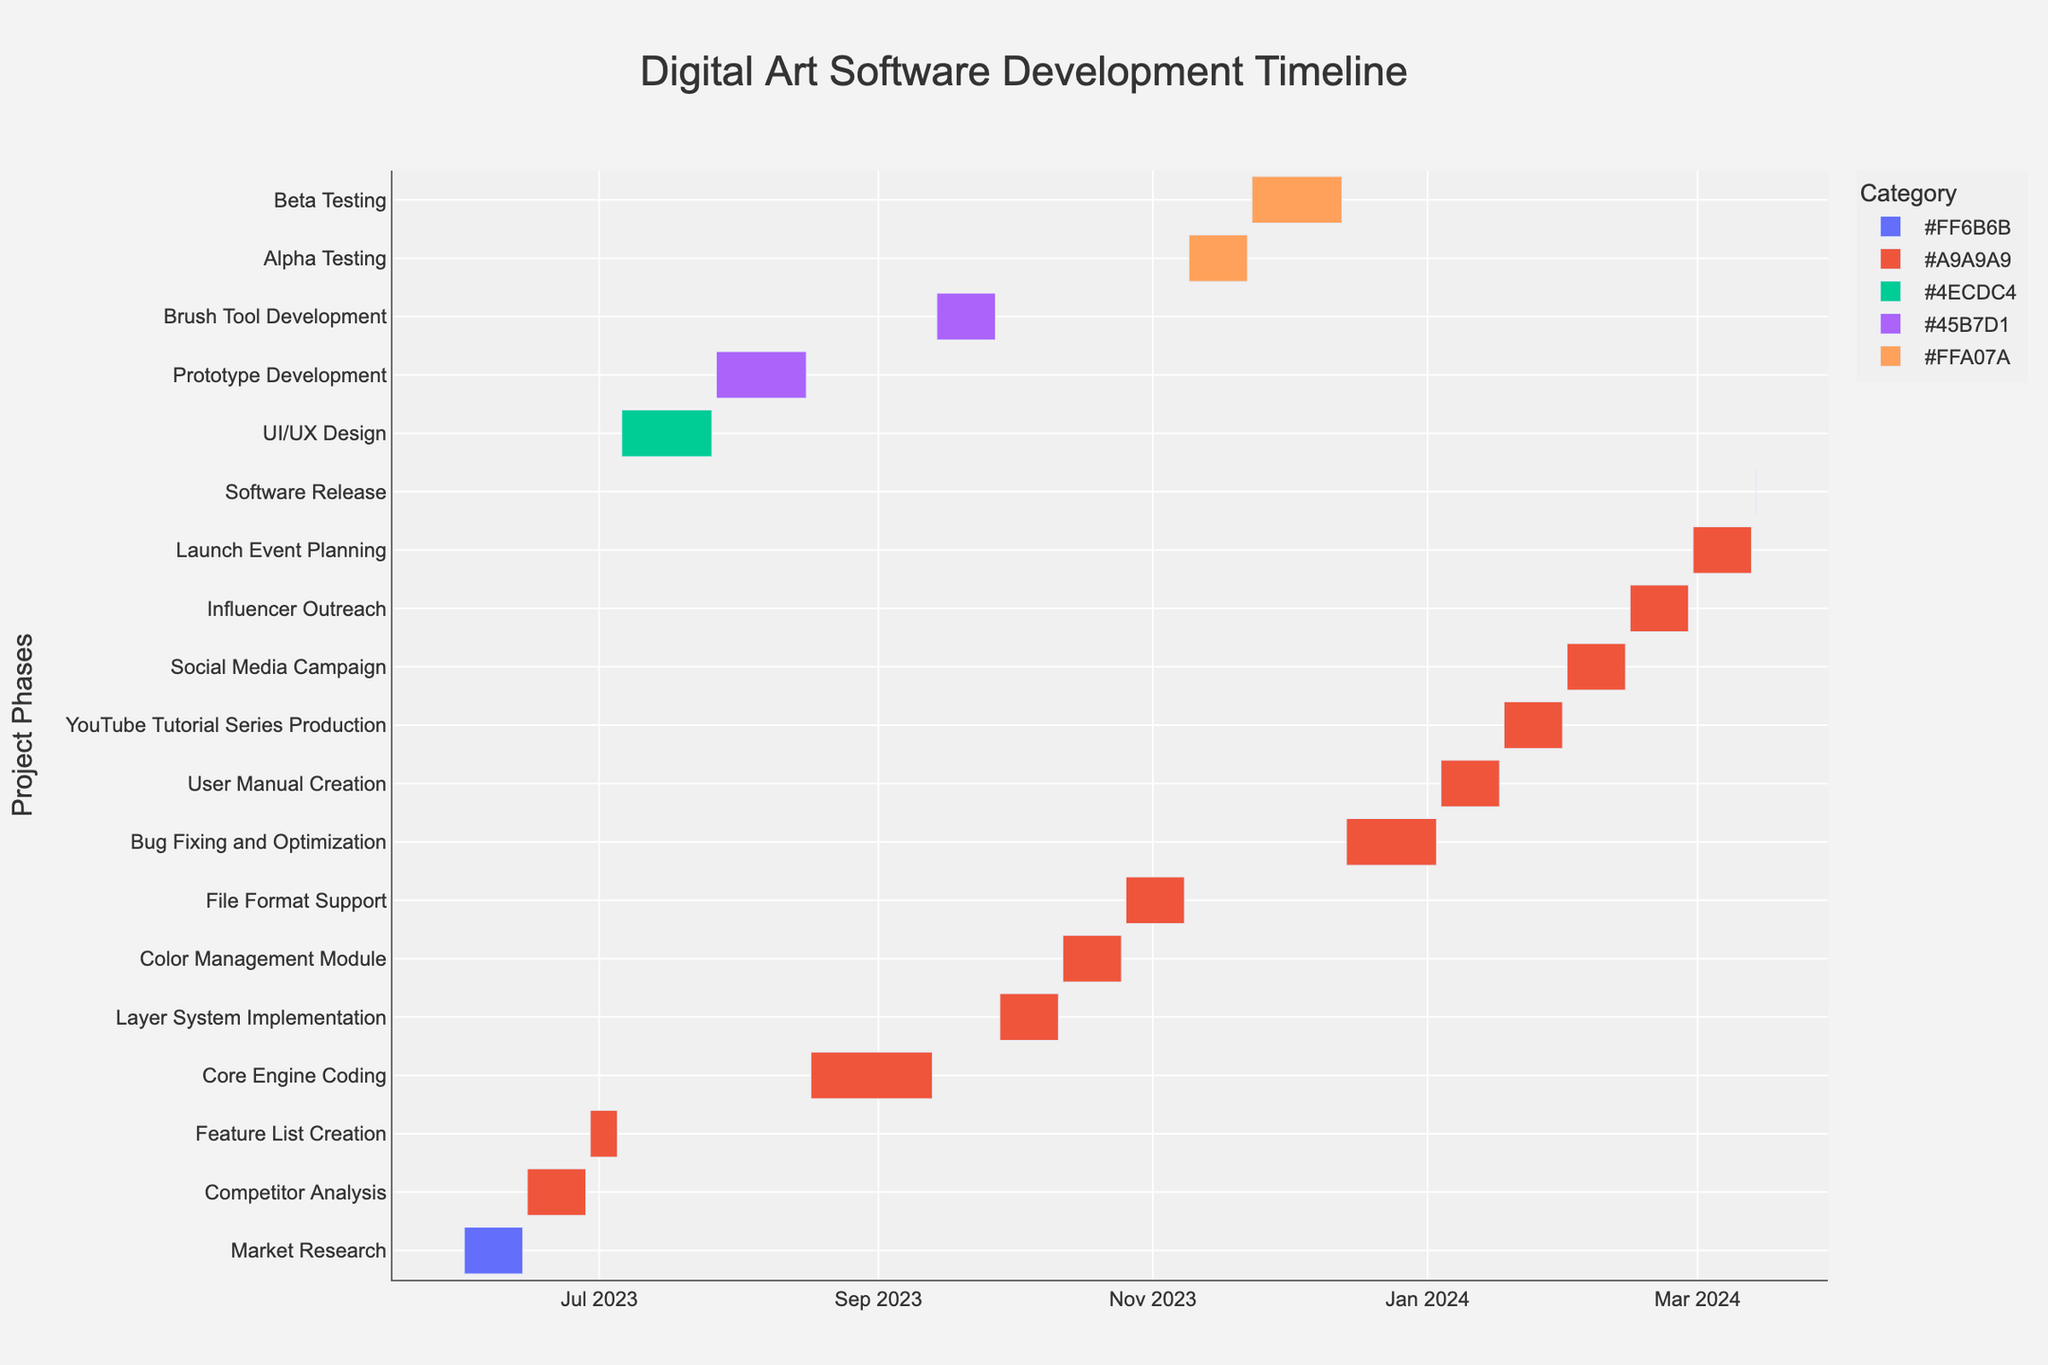What is the title of the Gantt chart? The title of the Gantt chart is prominently displayed at the top of the figure.
Answer: Digital Art Software Development Timeline What is the duration of the Market Research phase? The duration is shown directly in the figure under the Market Research task.
Answer: 14 days Which task has the longest duration? By visually comparing the lengths of the bars, the Core Engine Coding task has the longest duration.
Answer: Core Engine Coding When does the Prototype Development phase end? The end date of the Prototype Development phase is shown on the timeline at the rightmost edge of the bar for that task.
Answer: 2023-08-16 What's the overall duration of the Development phases? Add the durations for Prototype Development, Core Engine Coding, Brush Tool Development, Layer System Implementation, Color Management Module, and File Format Support (21 + 28 + 14 + 14 + 14 + 14 = 105).
Answer: 105 days How does the duration of Alpha Testing compare to Beta Testing? Beta Testing has a longer duration. Alpha Testing lasts for 14 days, while Beta Testing lasts for 21 days.
Answer: Beta Testing is longer What color represents the Design phase on the Gantt chart? The color is observed from the bars of UI/UX Design, which fall under the Design phase.
Answer: Teal Which phase begins right after the UI/UX Design? The next phase after UI/UX Design is Prototype Development, as sequentially indicated on the Gantt chart.
Answer: Prototype Development How long is the time span from the beginning of Market Research to the Software Release? The timeline starts on 2023-06-01 and ends on 2024-03-14. Calculating the total days between these dates gives a span of 287 days.
Answer: 287 days 